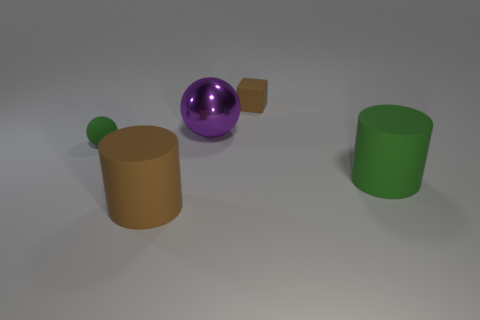Is there a cylinder that has the same material as the large brown object?
Keep it short and to the point. Yes. Does the thing on the left side of the large brown rubber cylinder have the same color as the matte cube?
Your answer should be very brief. No. Are there the same number of tiny brown matte objects that are in front of the big green thing and large cyan rubber spheres?
Provide a short and direct response. Yes. Are there any big things that have the same color as the cube?
Your answer should be compact. Yes. Do the cube and the brown cylinder have the same size?
Ensure brevity in your answer.  No. How big is the rubber object that is in front of the green rubber thing that is right of the metallic object?
Your answer should be very brief. Large. There is a object that is both on the left side of the small block and behind the green rubber ball; how big is it?
Provide a succinct answer. Large. What number of shiny spheres are the same size as the green rubber ball?
Provide a succinct answer. 0. How many metallic objects are small cyan cylinders or tiny brown blocks?
Provide a succinct answer. 0. There is a small object that is right of the large thing behind the tiny green thing; what is its material?
Make the answer very short. Rubber. 